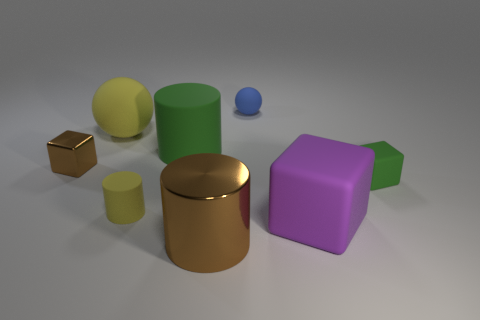Subtract all matte cylinders. How many cylinders are left? 1 Add 1 brown cylinders. How many objects exist? 9 Subtract all brown cylinders. How many cylinders are left? 2 Subtract 1 cylinders. How many cylinders are left? 2 Add 2 small yellow things. How many small yellow things exist? 3 Subtract 0 red blocks. How many objects are left? 8 Subtract all blocks. How many objects are left? 5 Subtract all cyan balls. Subtract all purple cubes. How many balls are left? 2 Subtract all gray blocks. How many blue cylinders are left? 0 Subtract all large yellow things. Subtract all blue things. How many objects are left? 6 